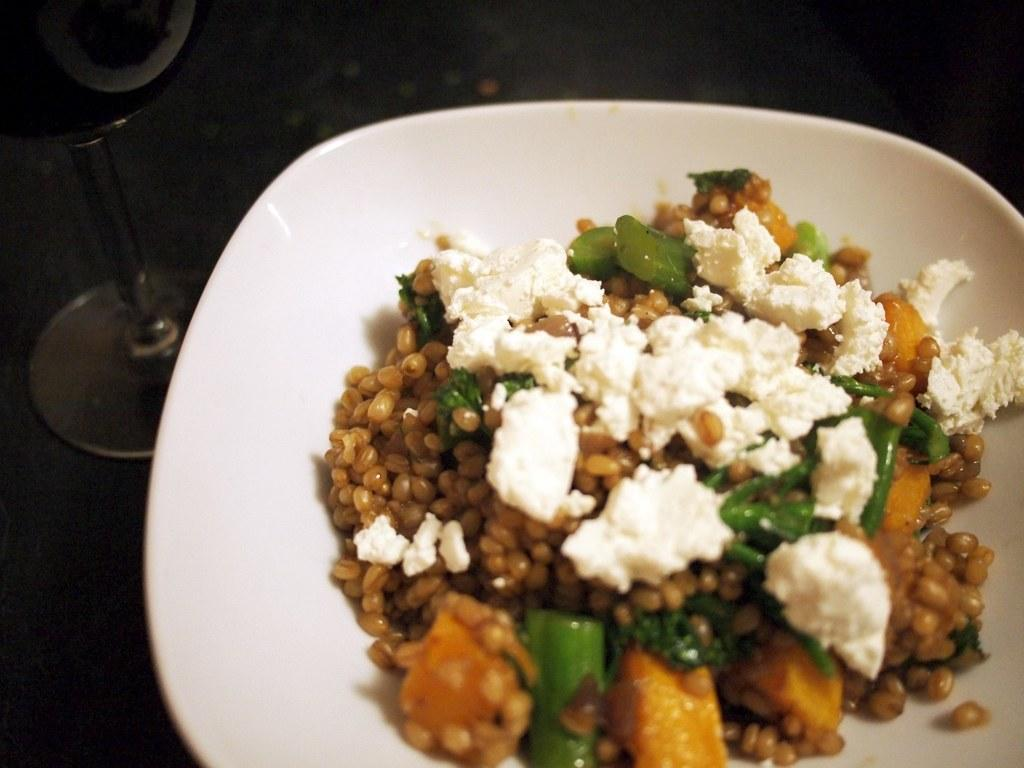What is present in the image? There is a bowl in the image. What is inside the bowl? The bowl contains food items. What type of mark can be seen on the wall behind the bowl? There is no mention of a mark on the wall behind the bowl in the provided facts, so it cannot be determined from the image. 